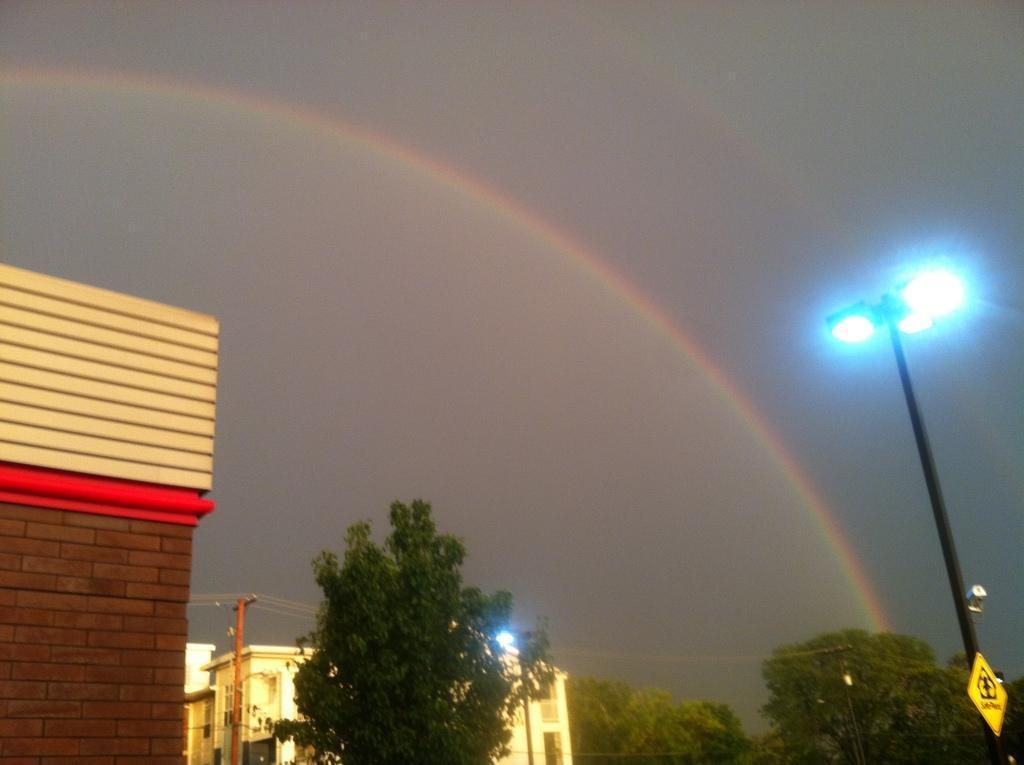In one or two sentences, can you explain what this image depicts? In this image there are trees, buildings and light pole, in the background there is the sky and a rainbow in the sky. 